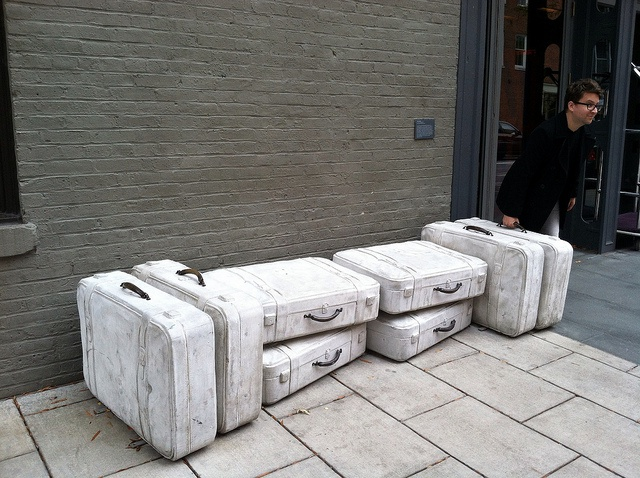Describe the objects in this image and their specific colors. I can see suitcase in black, darkgray, lightgray, and gray tones, suitcase in black, white, darkgray, and gray tones, suitcase in black, lightgray, darkgray, and gray tones, people in black, maroon, brown, and gray tones, and suitcase in black, white, darkgray, and gray tones in this image. 